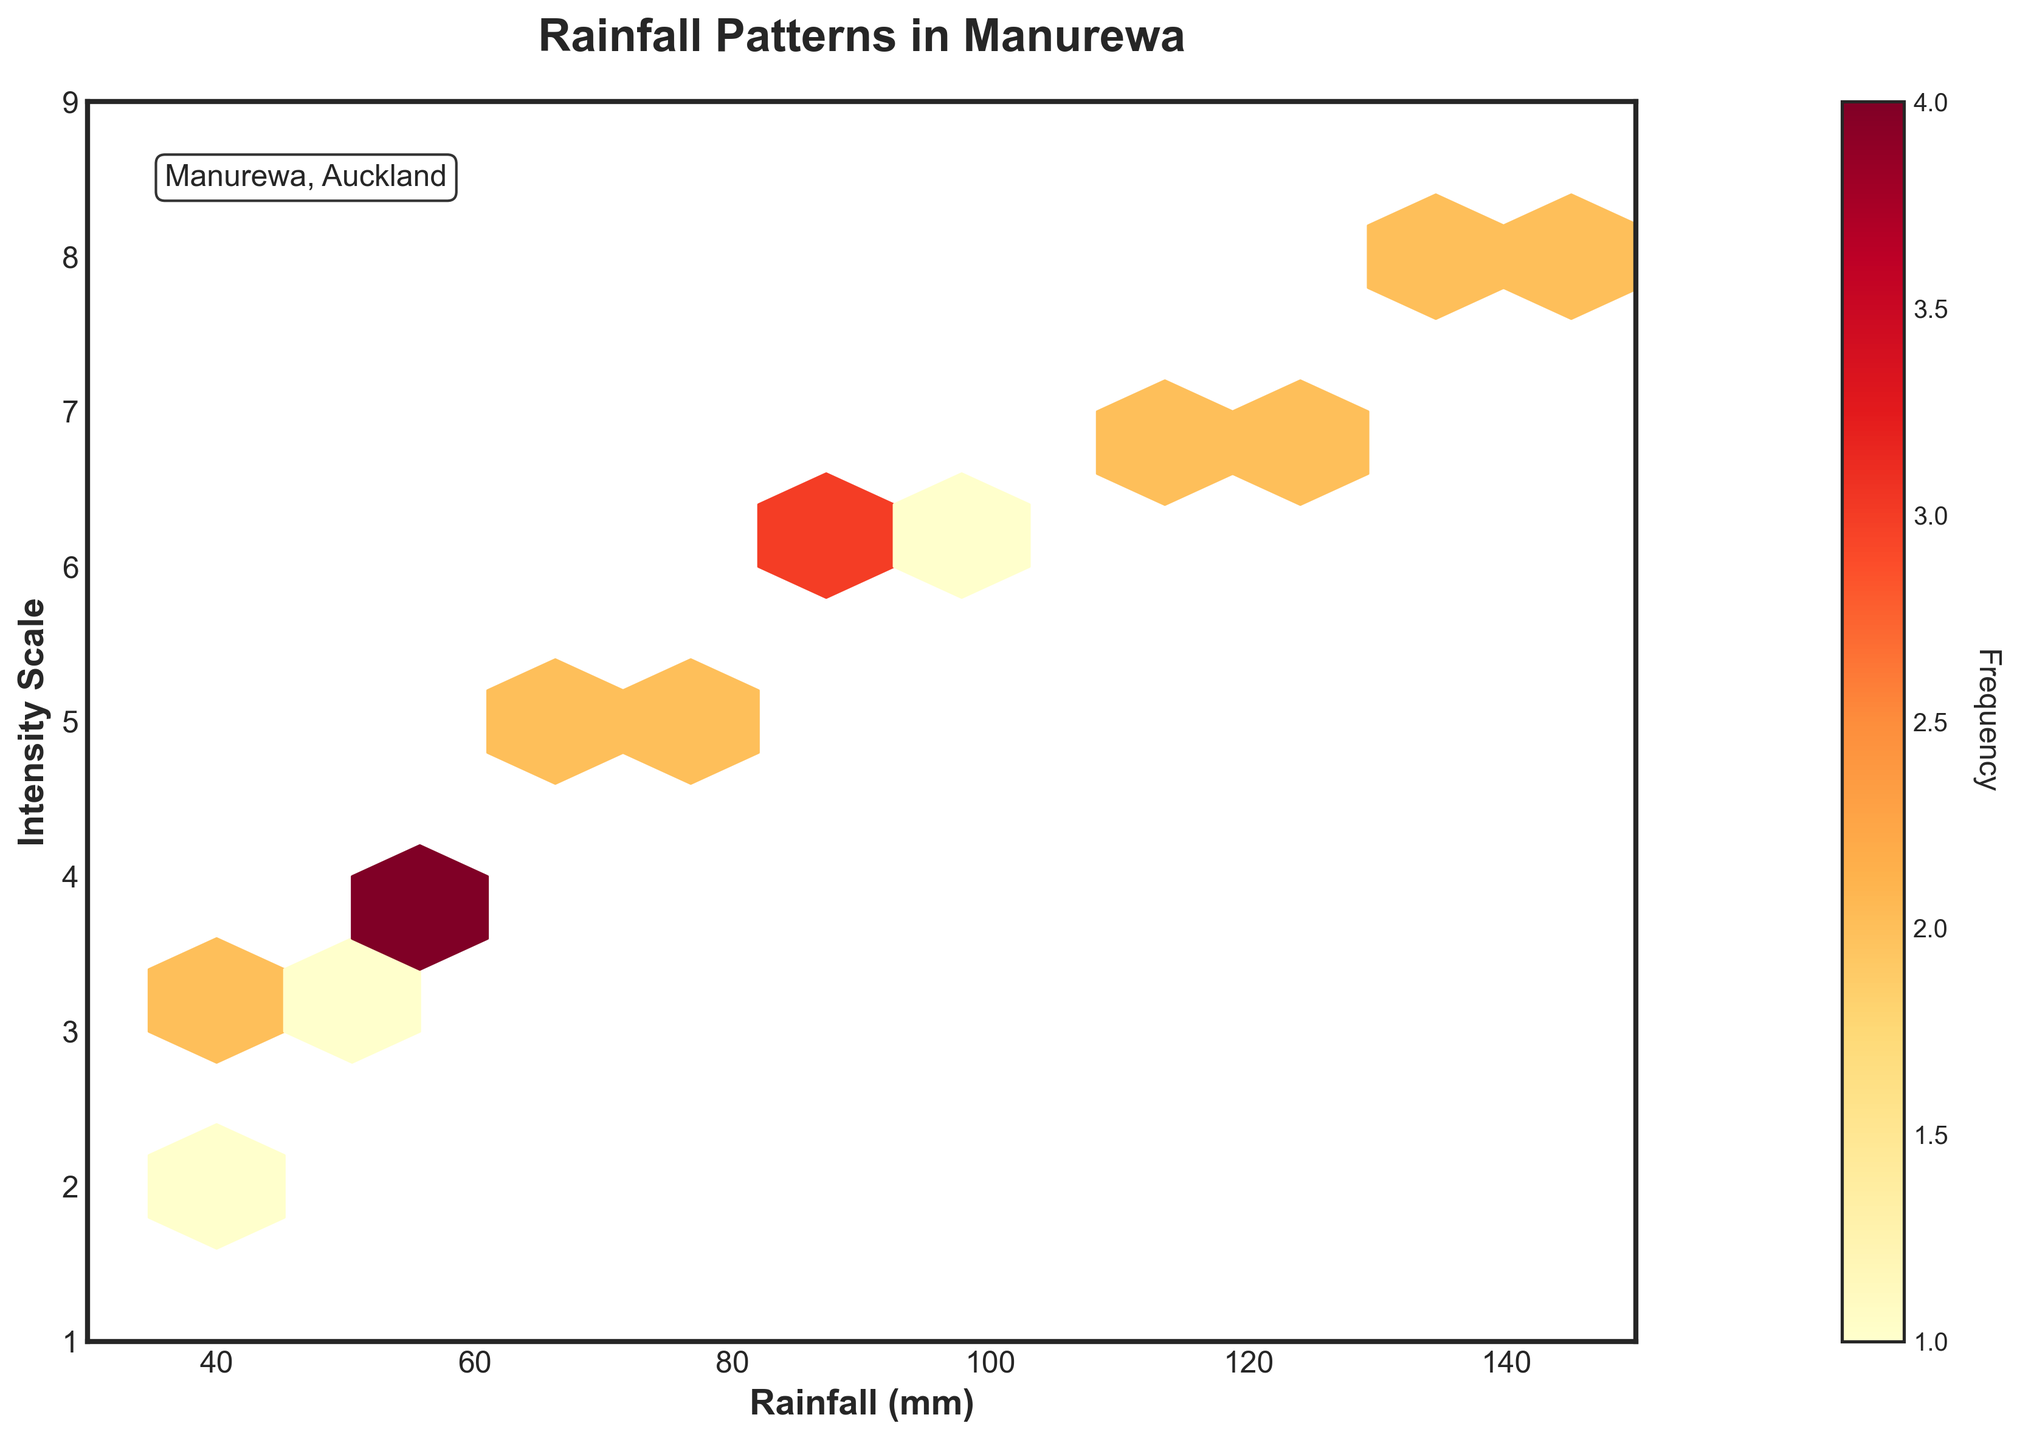What is the title of the hexbin plot? The title is typically the text displayed at the top of the figure, providing a summary of what the figure represents. This plot's title is clearly stated at the top.
Answer: Rainfall Patterns in Manurewa Which axis represents the Rainfall (mm)? The axis labels provide information about what the axis represents. By checking the labels, we can identify that Rainfall (mm) is on the horizontal axis.
Answer: Horizontal axis What is the color of the hexagons represents in the plot? The color of the hexagons indicates the frequency of data points in those hexagons. The color bar shows the range from yellow to red, where yellow represents lower frequency and red represents higher frequency.
Answer: Yellow to red What is the range of the Rainfall (mm) in the plot? The x-axis limits determine the range of Rainfall (mm) values. By referring to the axis ticks, the range is from 30 mm to 150 mm.
Answer: 30 to 150 mm How many hexagons show the highest frequency of data points? By observing the color distribution and referring to the color bar, we identify the hexagons with the deepest red color for the highest frequency. There appears to be one hexagon with the highest frequency.
Answer: One What is the relationship between intensity scale and rainfall patterns throughout the months? By examining the overall trend in the plot, we see that as the rainfall (mm) increases, the intensity scale also tends to increase. This indicates a positive relationship between rainfall and intensity scale.
Answer: Positive relationship Which month shows the highest rainfall and intensity scale? To determine this, we need to look at the plotted points and find the data point at the highest position on the x-axis (rainfall) and y-axis (intensity scale). June shows the highest values on both axes with 145 mm of rainfall and an intensity scale of 8.
Answer: June On average, how does the intensity scale fluctuate with respect to rainfall throughout the year? By examining the density and spread of hexagons along the x-axis and considering the color intensity (frequency), we observe that higher rainfall tends to have a higher average intensity scale. This suggests that on average, higher rainfall is associated with higher intensity.
Answer: Higher rainfall tends to have higher intensity Compare the rainfall and intensity of July and December. Which one has higher values? Locate the plotted points for July and December. July has rainfall values at 130-135 mm and intensity at 8, while December has rainfall around 45-50 mm and intensity at 3. Comparing these, July has higher values for both rainfall and intensity.
Answer: July What does the color bar on the right side represent? The color bar provides a visual representation of how frequency is mapped to colors in the hexbin plot. Higher color intensity (towards red) indicates a higher frequency of data points in that bin.
Answer: Frequency 